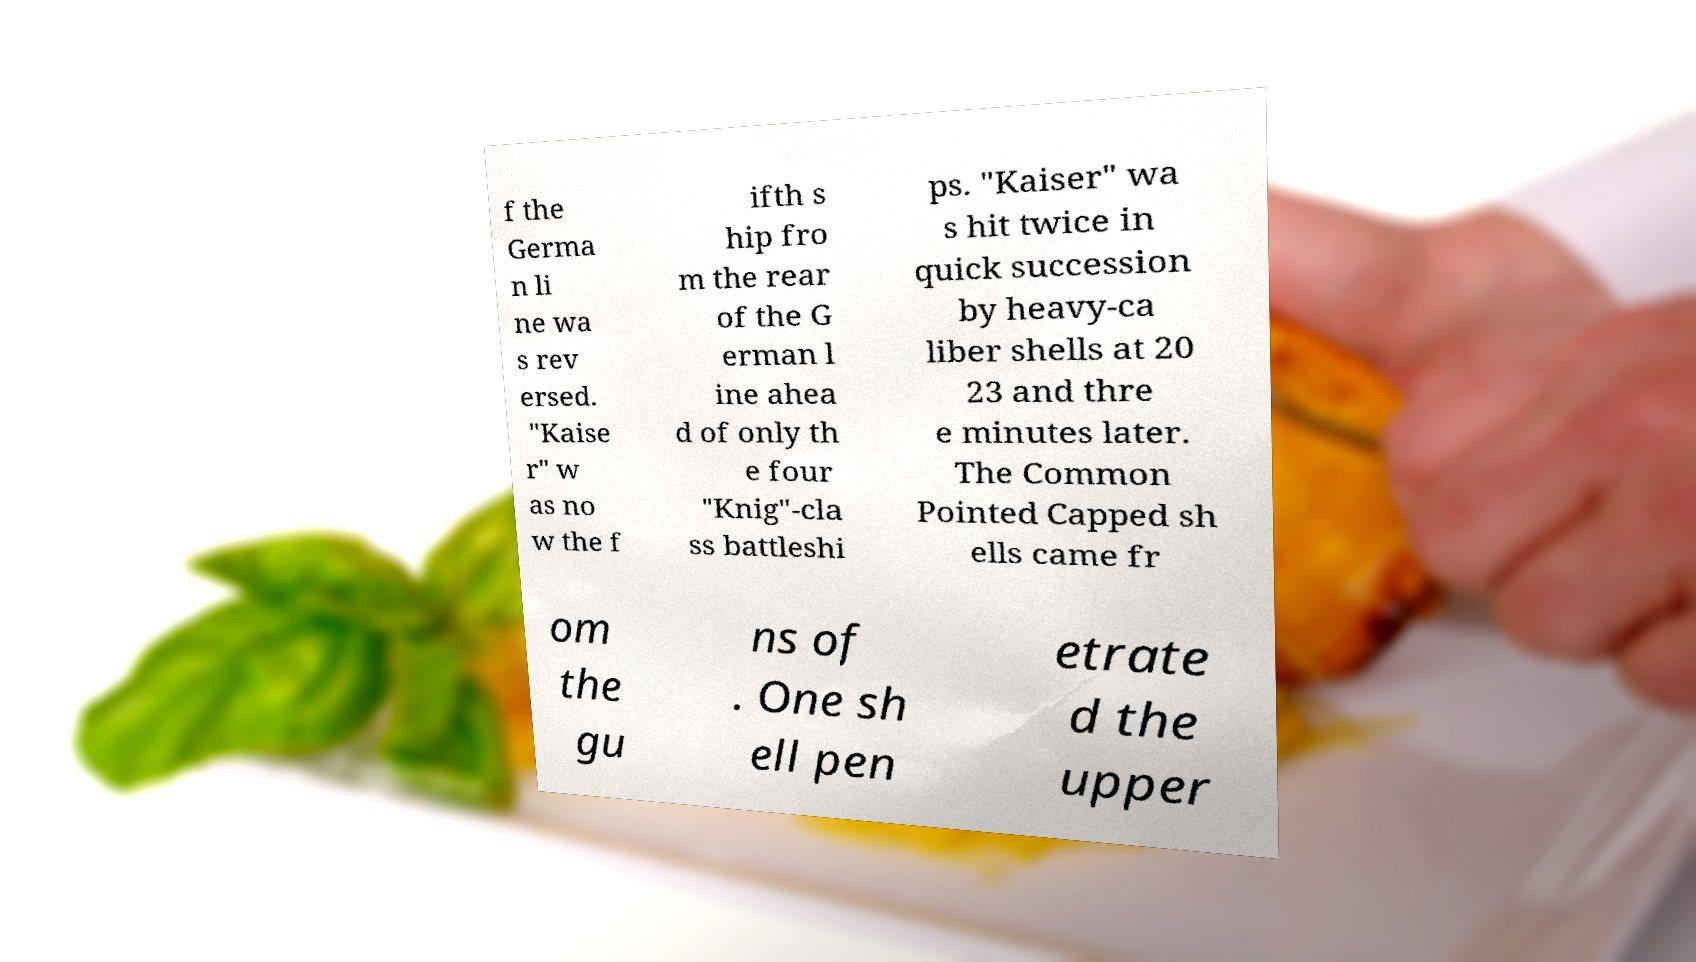Can you read and provide the text displayed in the image?This photo seems to have some interesting text. Can you extract and type it out for me? f the Germa n li ne wa s rev ersed. "Kaise r" w as no w the f ifth s hip fro m the rear of the G erman l ine ahea d of only th e four "Knig"-cla ss battleshi ps. "Kaiser" wa s hit twice in quick succession by heavy-ca liber shells at 20 23 and thre e minutes later. The Common Pointed Capped sh ells came fr om the gu ns of . One sh ell pen etrate d the upper 